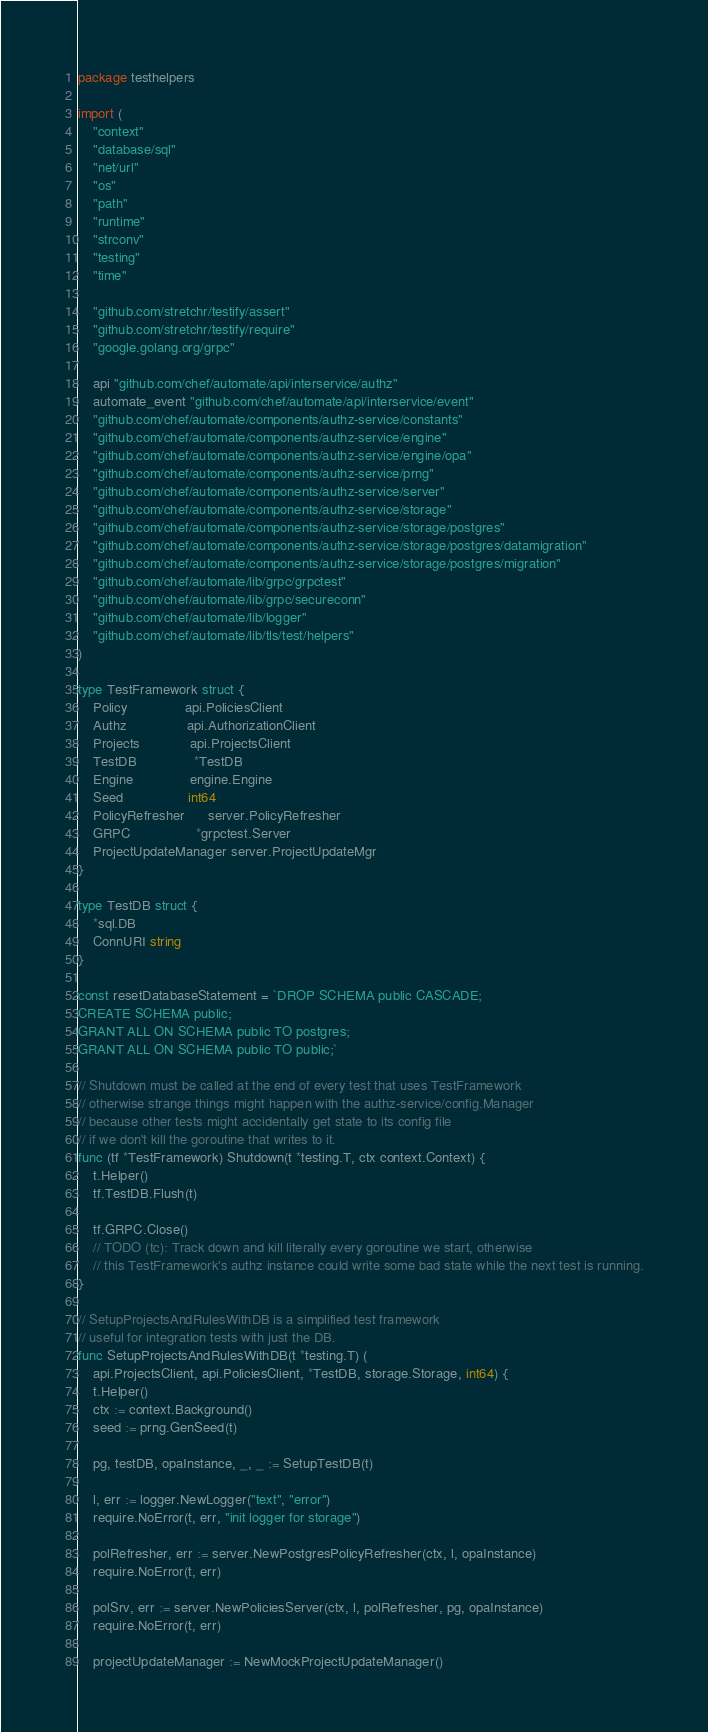Convert code to text. <code><loc_0><loc_0><loc_500><loc_500><_Go_>package testhelpers

import (
	"context"
	"database/sql"
	"net/url"
	"os"
	"path"
	"runtime"
	"strconv"
	"testing"
	"time"

	"github.com/stretchr/testify/assert"
	"github.com/stretchr/testify/require"
	"google.golang.org/grpc"

	api "github.com/chef/automate/api/interservice/authz"
	automate_event "github.com/chef/automate/api/interservice/event"
	"github.com/chef/automate/components/authz-service/constants"
	"github.com/chef/automate/components/authz-service/engine"
	"github.com/chef/automate/components/authz-service/engine/opa"
	"github.com/chef/automate/components/authz-service/prng"
	"github.com/chef/automate/components/authz-service/server"
	"github.com/chef/automate/components/authz-service/storage"
	"github.com/chef/automate/components/authz-service/storage/postgres"
	"github.com/chef/automate/components/authz-service/storage/postgres/datamigration"
	"github.com/chef/automate/components/authz-service/storage/postgres/migration"
	"github.com/chef/automate/lib/grpc/grpctest"
	"github.com/chef/automate/lib/grpc/secureconn"
	"github.com/chef/automate/lib/logger"
	"github.com/chef/automate/lib/tls/test/helpers"
)

type TestFramework struct {
	Policy               api.PoliciesClient
	Authz                api.AuthorizationClient
	Projects             api.ProjectsClient
	TestDB               *TestDB
	Engine               engine.Engine
	Seed                 int64
	PolicyRefresher      server.PolicyRefresher
	GRPC                 *grpctest.Server
	ProjectUpdateManager server.ProjectUpdateMgr
}

type TestDB struct {
	*sql.DB
	ConnURI string
}

const resetDatabaseStatement = `DROP SCHEMA public CASCADE;
CREATE SCHEMA public;
GRANT ALL ON SCHEMA public TO postgres;
GRANT ALL ON SCHEMA public TO public;`

// Shutdown must be called at the end of every test that uses TestFramework
// otherwise strange things might happen with the authz-service/config.Manager
// because other tests might accidentally get state to its config file
// if we don't kill the goroutine that writes to it.
func (tf *TestFramework) Shutdown(t *testing.T, ctx context.Context) {
	t.Helper()
	tf.TestDB.Flush(t)

	tf.GRPC.Close()
	// TODO (tc): Track down and kill literally every goroutine we start, otherwise
	// this TestFramework's authz instance could write some bad state while the next test is running.
}

// SetupProjectsAndRulesWithDB is a simplified test framework
// useful for integration tests with just the DB.
func SetupProjectsAndRulesWithDB(t *testing.T) (
	api.ProjectsClient, api.PoliciesClient, *TestDB, storage.Storage, int64) {
	t.Helper()
	ctx := context.Background()
	seed := prng.GenSeed(t)

	pg, testDB, opaInstance, _, _ := SetupTestDB(t)

	l, err := logger.NewLogger("text", "error")
	require.NoError(t, err, "init logger for storage")

	polRefresher, err := server.NewPostgresPolicyRefresher(ctx, l, opaInstance)
	require.NoError(t, err)

	polSrv, err := server.NewPoliciesServer(ctx, l, polRefresher, pg, opaInstance)
	require.NoError(t, err)

	projectUpdateManager := NewMockProjectUpdateManager()</code> 